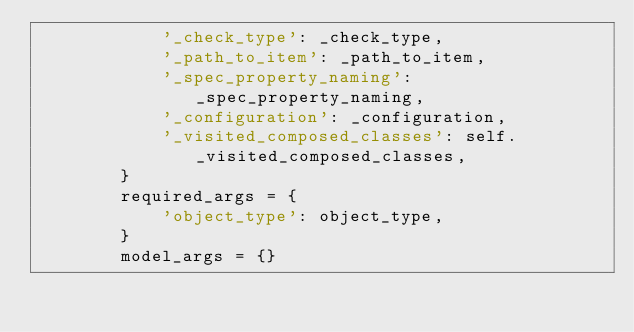<code> <loc_0><loc_0><loc_500><loc_500><_Python_>            '_check_type': _check_type,
            '_path_to_item': _path_to_item,
            '_spec_property_naming': _spec_property_naming,
            '_configuration': _configuration,
            '_visited_composed_classes': self._visited_composed_classes,
        }
        required_args = {
            'object_type': object_type,
        }
        model_args = {}</code> 